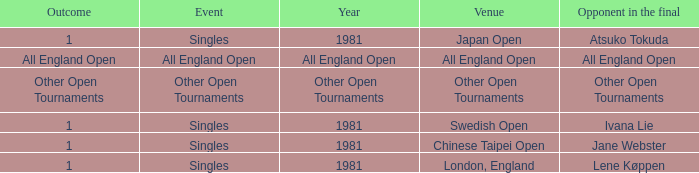What Event has an Outcome of other open tournaments? Other Open Tournaments. 